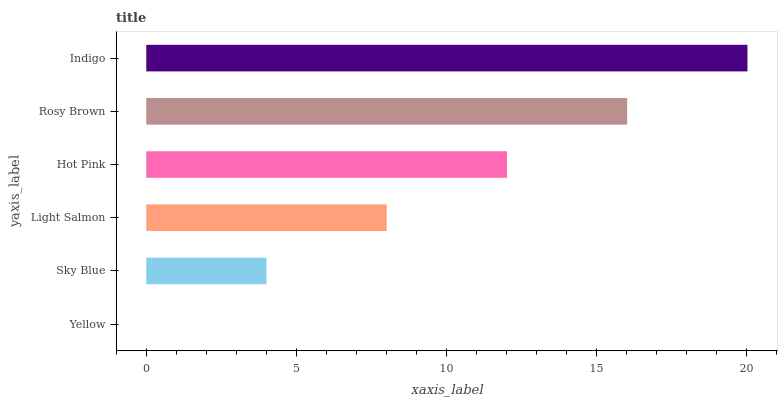Is Yellow the minimum?
Answer yes or no. Yes. Is Indigo the maximum?
Answer yes or no. Yes. Is Sky Blue the minimum?
Answer yes or no. No. Is Sky Blue the maximum?
Answer yes or no. No. Is Sky Blue greater than Yellow?
Answer yes or no. Yes. Is Yellow less than Sky Blue?
Answer yes or no. Yes. Is Yellow greater than Sky Blue?
Answer yes or no. No. Is Sky Blue less than Yellow?
Answer yes or no. No. Is Hot Pink the high median?
Answer yes or no. Yes. Is Light Salmon the low median?
Answer yes or no. Yes. Is Sky Blue the high median?
Answer yes or no. No. Is Hot Pink the low median?
Answer yes or no. No. 